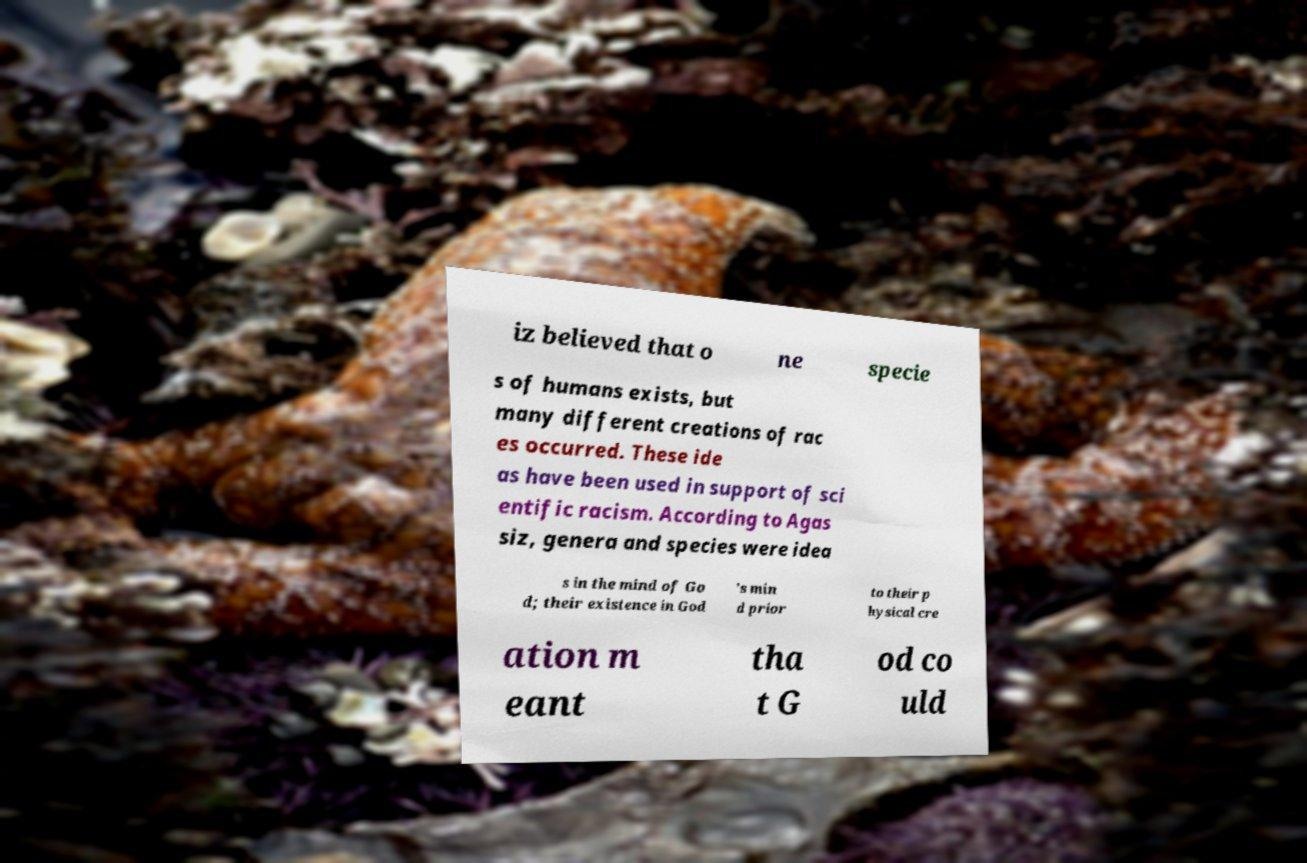What messages or text are displayed in this image? I need them in a readable, typed format. iz believed that o ne specie s of humans exists, but many different creations of rac es occurred. These ide as have been used in support of sci entific racism. According to Agas siz, genera and species were idea s in the mind of Go d; their existence in God 's min d prior to their p hysical cre ation m eant tha t G od co uld 